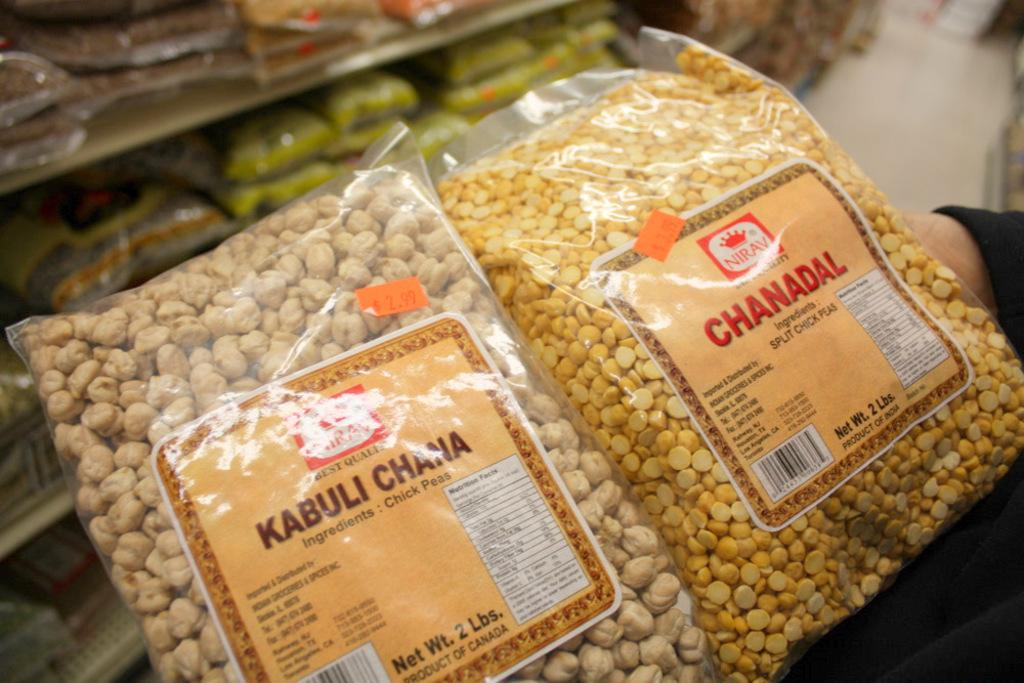What type of location is depicted in the image? The image appears to be a shopping mall. What is the person holding in the image? The person is holding two packets of chana dal. What can be seen on the shelves in the image? There are shelves with packets visible in the image. How many wings does the person have in the image? The person in the image does not have any wings; they are a regular person holding chana dal packets. 